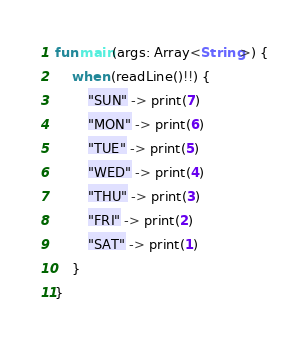<code> <loc_0><loc_0><loc_500><loc_500><_Kotlin_>fun main(args: Array<String>) {
    when (readLine()!!) {
        "SUN" -> print(7)
        "MON" -> print(6)
        "TUE" -> print(5)
        "WED" -> print(4)
        "THU" -> print(3)
        "FRI" -> print(2)
        "SAT" -> print(1)
    }
}
</code> 